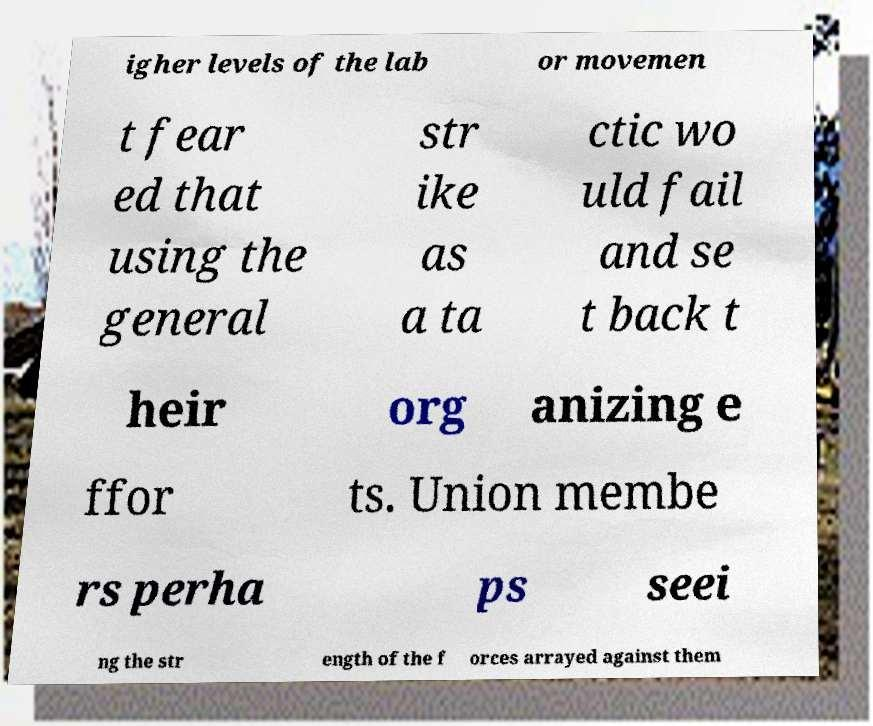There's text embedded in this image that I need extracted. Can you transcribe it verbatim? igher levels of the lab or movemen t fear ed that using the general str ike as a ta ctic wo uld fail and se t back t heir org anizing e ffor ts. Union membe rs perha ps seei ng the str ength of the f orces arrayed against them 